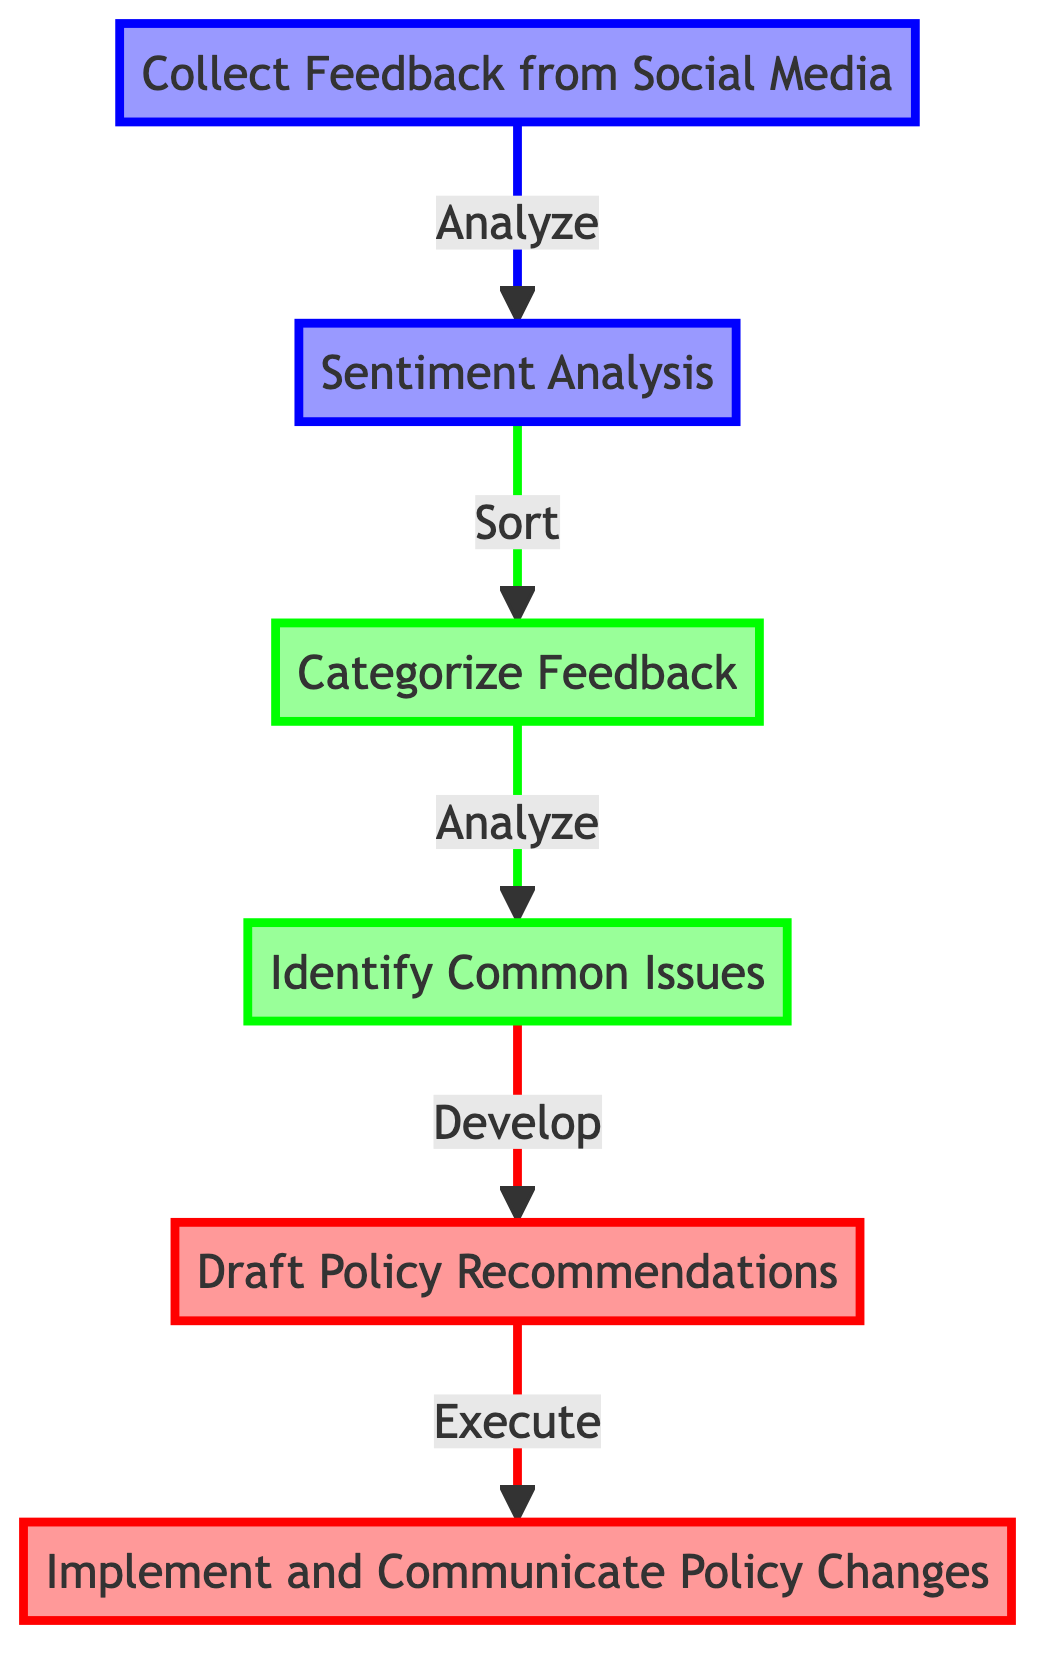What's the first step in the workflow? The first step is represented by the bottom node labeled "Collect Feedback from Social Media," indicating that this is where the process begins.
Answer: Collect Feedback from Social Media How many total steps are there in the workflow? The workflow consists of six steps starting from "Collect Feedback from Social Media" to "Implement and Communicate Policy Changes," so by counting the nodes, we find there are six steps in total.
Answer: Six What type of analysis is performed after collecting feedback? Following the feedback collection, the next step involves conducting "Sentiment Analysis" to assess the public sentiment of the gathered feedback.
Answer: Sentiment Analysis What is the relationship between "Categorize Feedback" and "Identify Common Issues"? "Categorize Feedback" is the step where feedback is sorted into key areas, which then feeds into "Identify Common Issues," for analyzing those categories for recurring themes, establishing a direct flow from one to the other.
Answer: Analyze What action is associated with the step "Draft Policy Recommendations"? The action linked to "Draft Policy Recommendations" involves the development of action plans and recommendations, addressing community concerns identified in previous steps.
Answer: Develop Which step occurs immediately before "Implement and Communicate Policy Changes"? Immediately preceding "Implement and Communicate Policy Changes" is "Draft Policy Recommendations," indicating that policy development comes directly before implementation.
Answer: Draft Policy Recommendations What do the colored nodes represent in the diagram? The colored nodes differentiate the steps into categories: bottom nodes are marked in blue, middle nodes in green, and top nodes in red, illustrating the progression and significance of each stage in the workflow.
Answer: Colors indicate node levels How does feedback flow from "Sentiment Analysis" to "Categorize Feedback"? Feedback flows from "Sentiment Analysis" to "Categorize Feedback" through a directed edge that signifies the action of sorting the analyzed feedback into categories for further analysis.
Answer: Sort What must be done before new policies are communicated to the community? Before new policies can be communicated to the community, they must be officially implemented, establishing a prerequisite relationship between policy implementation and communication.
Answer: Implement 